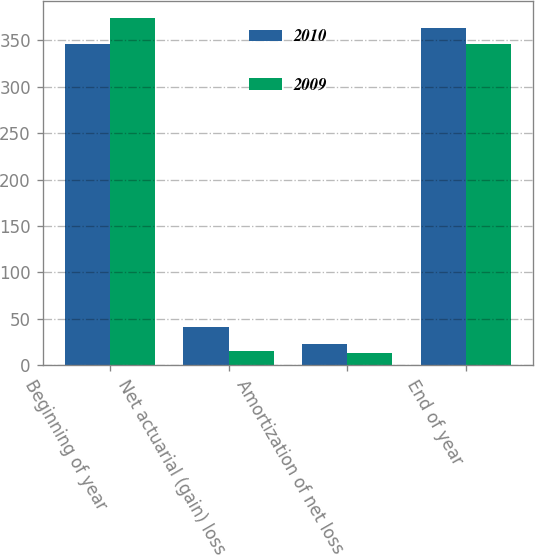Convert chart. <chart><loc_0><loc_0><loc_500><loc_500><stacked_bar_chart><ecel><fcel>Beginning of year<fcel>Net actuarial (gain) loss<fcel>Amortization of net loss<fcel>End of year<nl><fcel>2010<fcel>346<fcel>41<fcel>23<fcel>363<nl><fcel>2009<fcel>374<fcel>15<fcel>13<fcel>346<nl></chart> 